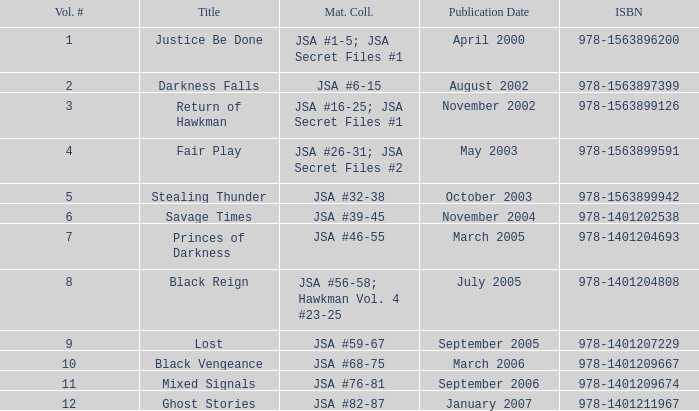How many "darkness falls" titles are there in terms of volume numbers? 2.0. 